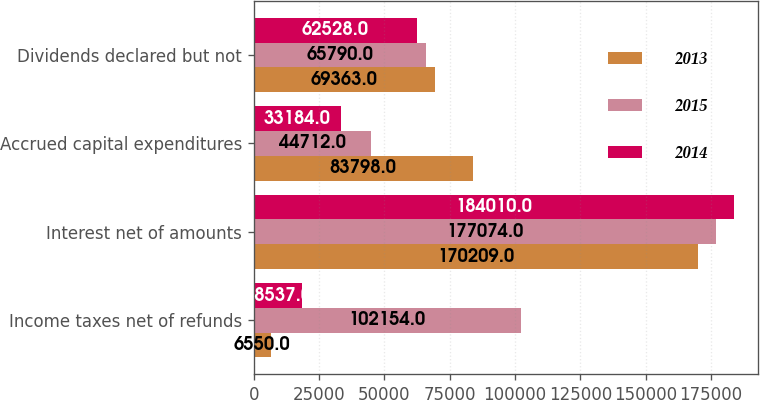Convert chart. <chart><loc_0><loc_0><loc_500><loc_500><stacked_bar_chart><ecel><fcel>Income taxes net of refunds<fcel>Interest net of amounts<fcel>Accrued capital expenditures<fcel>Dividends declared but not<nl><fcel>2013<fcel>6550<fcel>170209<fcel>83798<fcel>69363<nl><fcel>2015<fcel>102154<fcel>177074<fcel>44712<fcel>65790<nl><fcel>2014<fcel>18537<fcel>184010<fcel>33184<fcel>62528<nl></chart> 